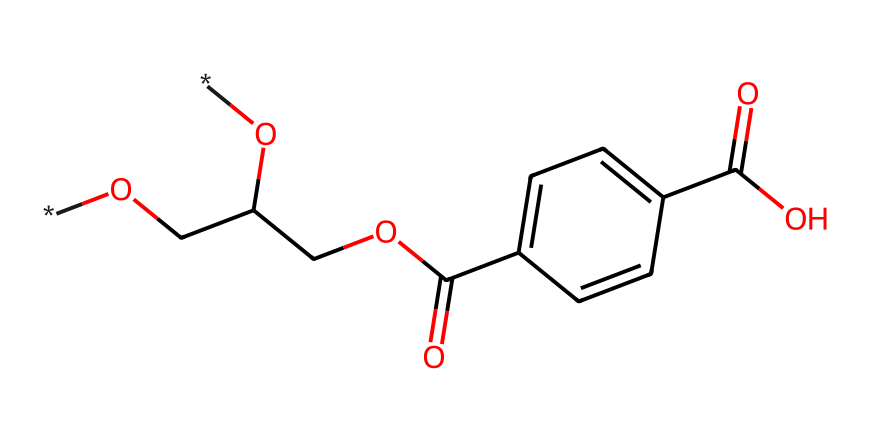what is the main component of polyethylene terephthalate? Polyethylene terephthalate is primarily made from the combination of ethylene glycol and terephthalic acid, which are represented in the SMILES string.
Answer: ethylene glycol and terephthalic acid how many carbon atoms are present in the structure? By analyzing the SMILES notation, we can count the carbon atoms within the entire structure. This gives us a total of 10 carbon atoms.
Answer: 10 does the presence of -COOH indicate any functionality? The presence of -COOH in the SMILES structure indicates that the compound has a carboxylic acid functional group, which is responsible for its acidic properties.
Answer: yes what type of polymer is polyethylene terephthalate? Polyethylene terephthalate is classified as a thermoplastic polyester, which is evident from the repeating ester linkages in the structure.
Answer: thermoplastic polyester how many oxygen atoms are in the chemical structure? From the SMILES string, we can identify the oxygen atoms present; counting yields a total of 4 oxygen atoms in the structure.
Answer: 4 is polyethylene terephthalate biodegradable? Polyethylene terephthalate is not biodegradable under natural conditions; instead, it is known for its durability and persistence in the environment.
Answer: no what is one common use of polyethylene terephthalate? A common use of polyethylene terephthalate is in the production of plastic bottles for beverages, including water bottles.
Answer: plastic bottles 